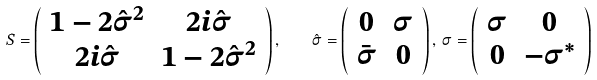Convert formula to latex. <formula><loc_0><loc_0><loc_500><loc_500>S = \left ( \begin{array} { c c } 1 - 2 \hat { \sigma } ^ { 2 } & 2 i \hat { \sigma } \\ 2 i \hat { \sigma } & 1 - 2 \hat { \sigma } ^ { 2 } \end{array} \right ) , \quad \hat { \sigma } = \left ( \begin{array} { c c } 0 & \sigma \\ \bar { \sigma } & 0 \end{array} \right ) , \, \sigma = \left ( \begin{array} { c c } \sigma & 0 \\ 0 & - \sigma ^ { * } \end{array} \right )</formula> 